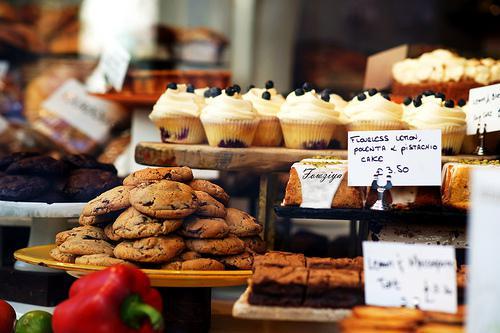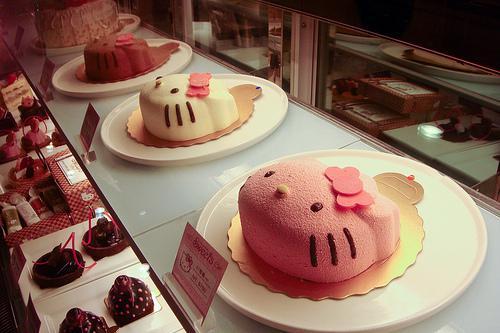The first image is the image on the left, the second image is the image on the right. Considering the images on both sides, is "A bakery display of assorted cakes and baked goods." valid? Answer yes or no. Yes. The first image is the image on the left, the second image is the image on the right. Assess this claim about the two images: "The left image shows rows of bakery items on display shelves, and includes brown-frosted log shapesnext to white frosted treats garnished with red berries.". Correct or not? Answer yes or no. No. 